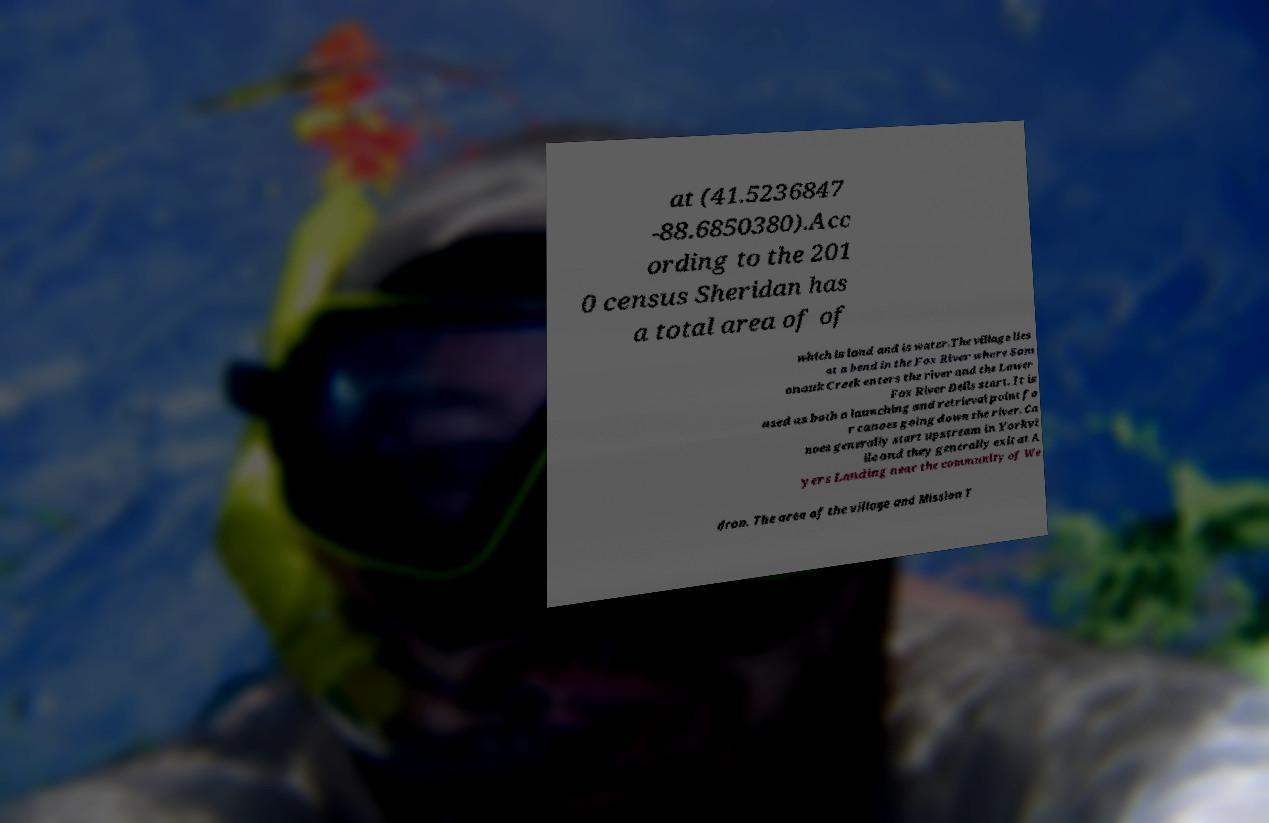Could you assist in decoding the text presented in this image and type it out clearly? at (41.5236847 -88.6850380).Acc ording to the 201 0 census Sheridan has a total area of of which is land and is water.The village lies at a bend in the Fox River where Som onauk Creek enters the river and the Lower Fox River Dells start. It is used as both a launching and retrieval point fo r canoes going down the river. Ca noes generally start upstream in Yorkvi lle and they generally exit at A yers Landing near the community of We dron. The area of the village and Mission T 